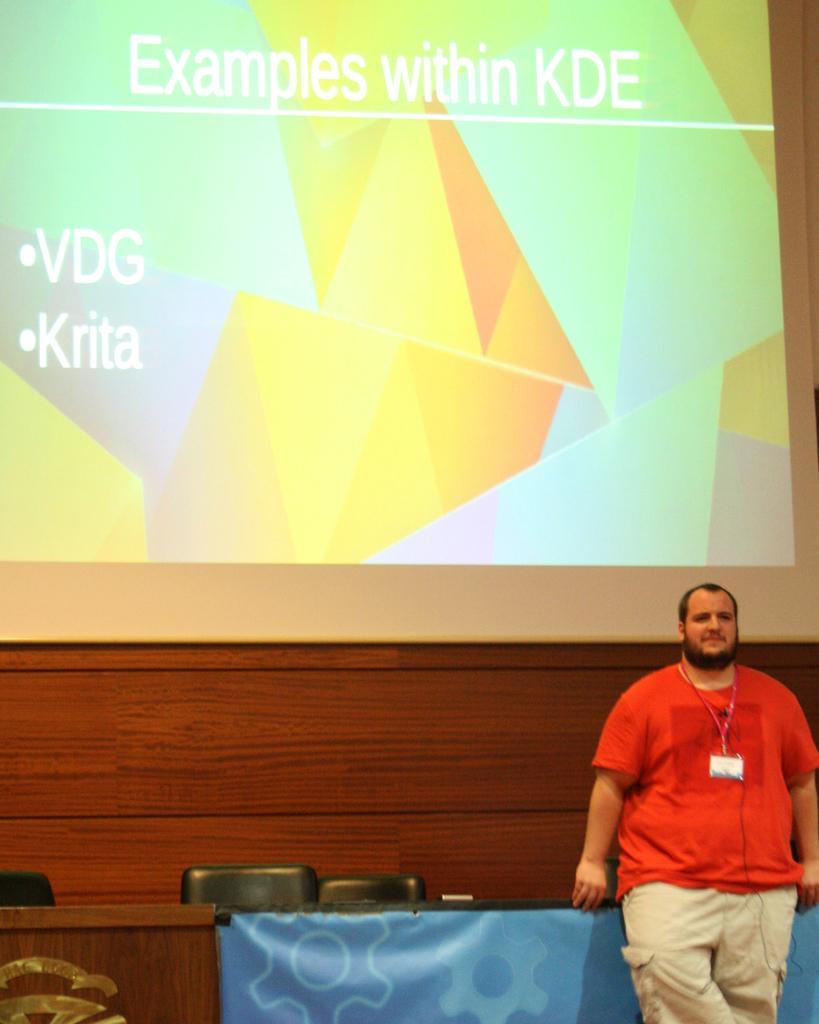Can you describe this image briefly? This picture shows a man standing and we see a table and a couple of chairs and we see a screen on the back 